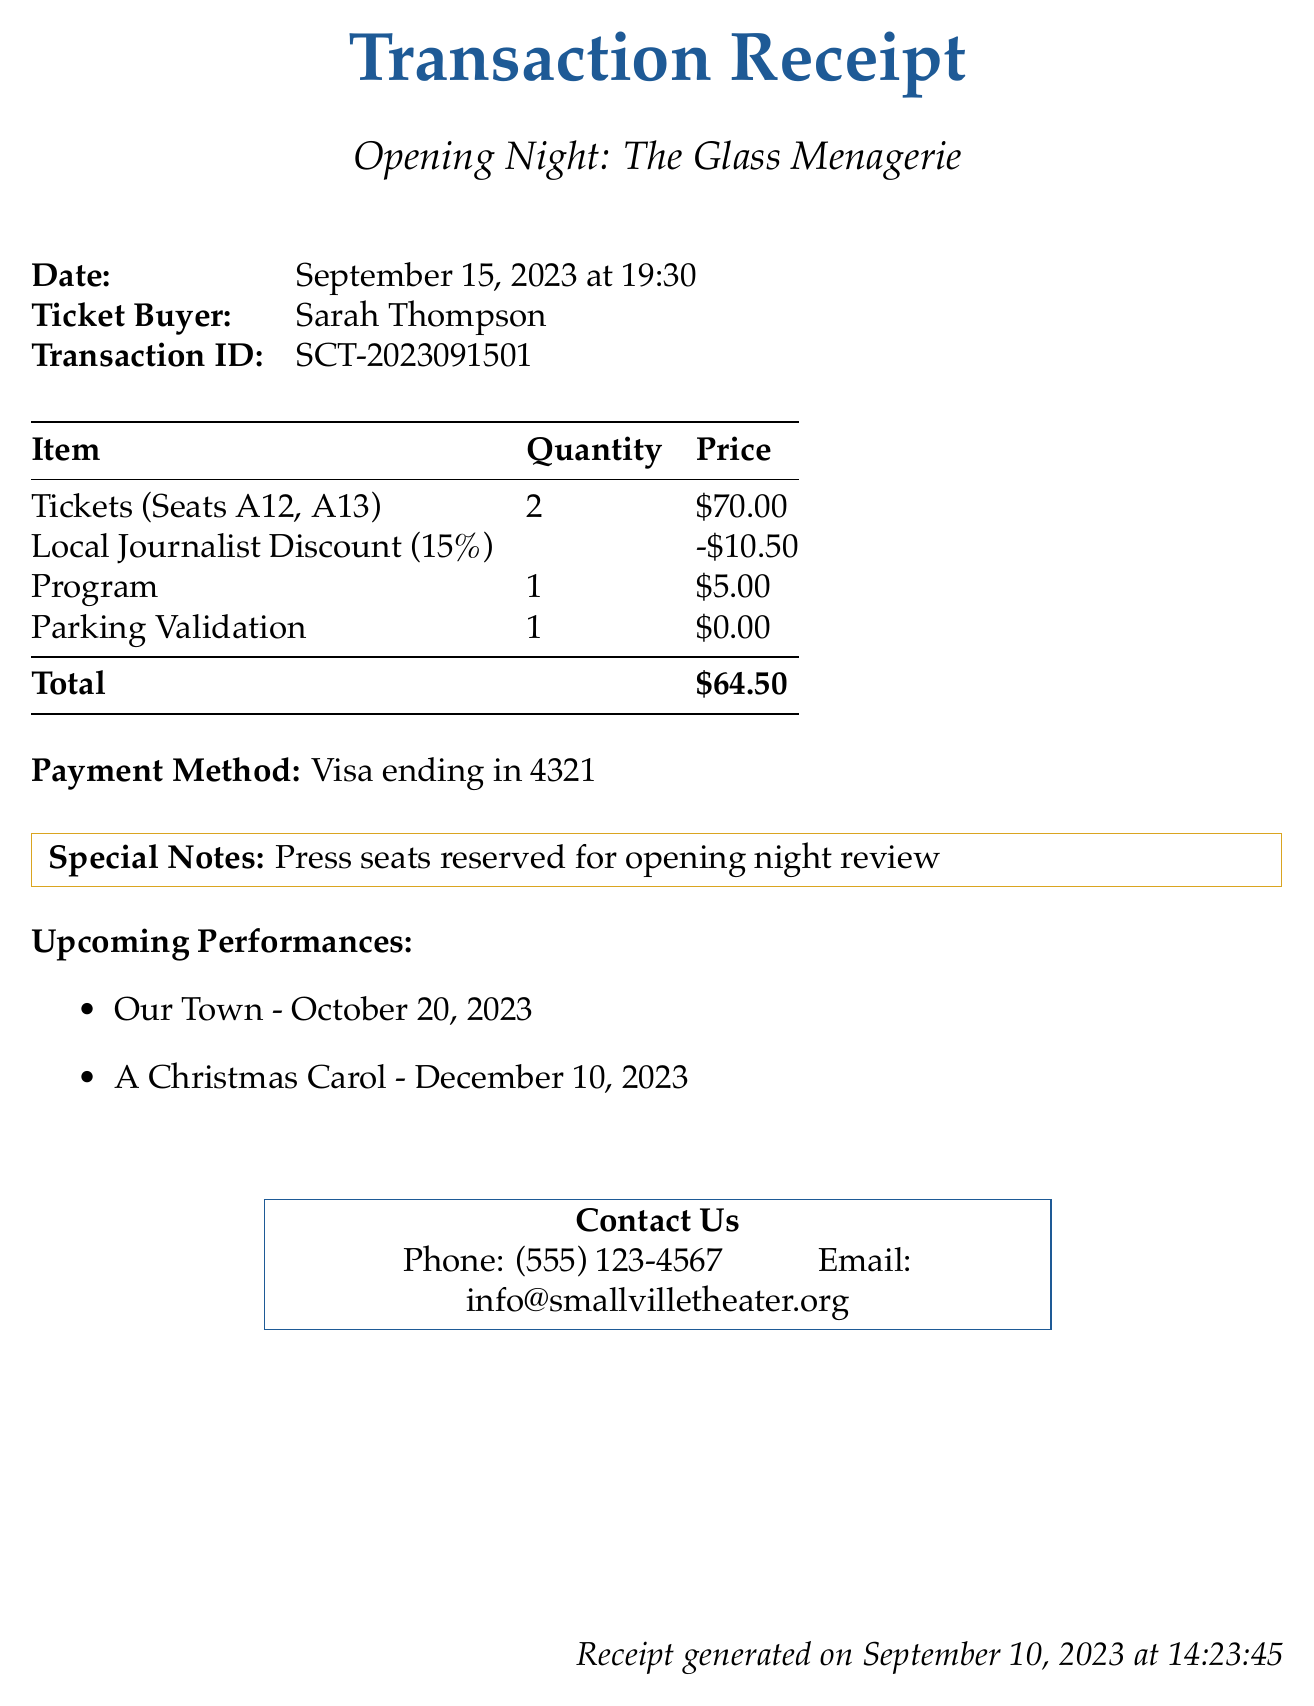What is the theater name? The theater name is specified in the document as the location of the performance.
Answer: Smallville Community Theater What is the title of the performance? The title of the performance is clearly identified in the document.
Answer: The Glass Menagerie What date is the performance? The performance date is explicitly listed in the document.
Answer: September 15, 2023 How many tickets were purchased? The number of tickets purchased is provided in the transaction details.
Answer: 2 What are the seat numbers? The seat numbers refer to the specific locations of the tickets bought, which are detailed in the document.
Answer: A12, A13 What is the total price after discounts? The total price is calculated in the document, considering the original price and applied discounts.
Answer: $59.50 Who processed the transaction? The box office agent's name is mentioned in the document as the person who assisted with the ticket purchase.
Answer: Emily Parker What discount was applied? The document states the percentage of the discount applied for local journalists.
Answer: 15% What is the payment method used? The payment method is outlined in the document to show how the transaction was completed.
Answer: Credit Card 